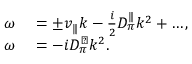Convert formula to latex. <formula><loc_0><loc_0><loc_500><loc_500>\begin{array} { r l } { \omega } & = \pm v _ { \| } k - \frac { i } { 2 } D _ { \pi } ^ { \| } k ^ { 2 } + \dots , } \\ { \omega } & = - i D _ { \pi } ^ { \perp } k ^ { 2 } . } \end{array}</formula> 